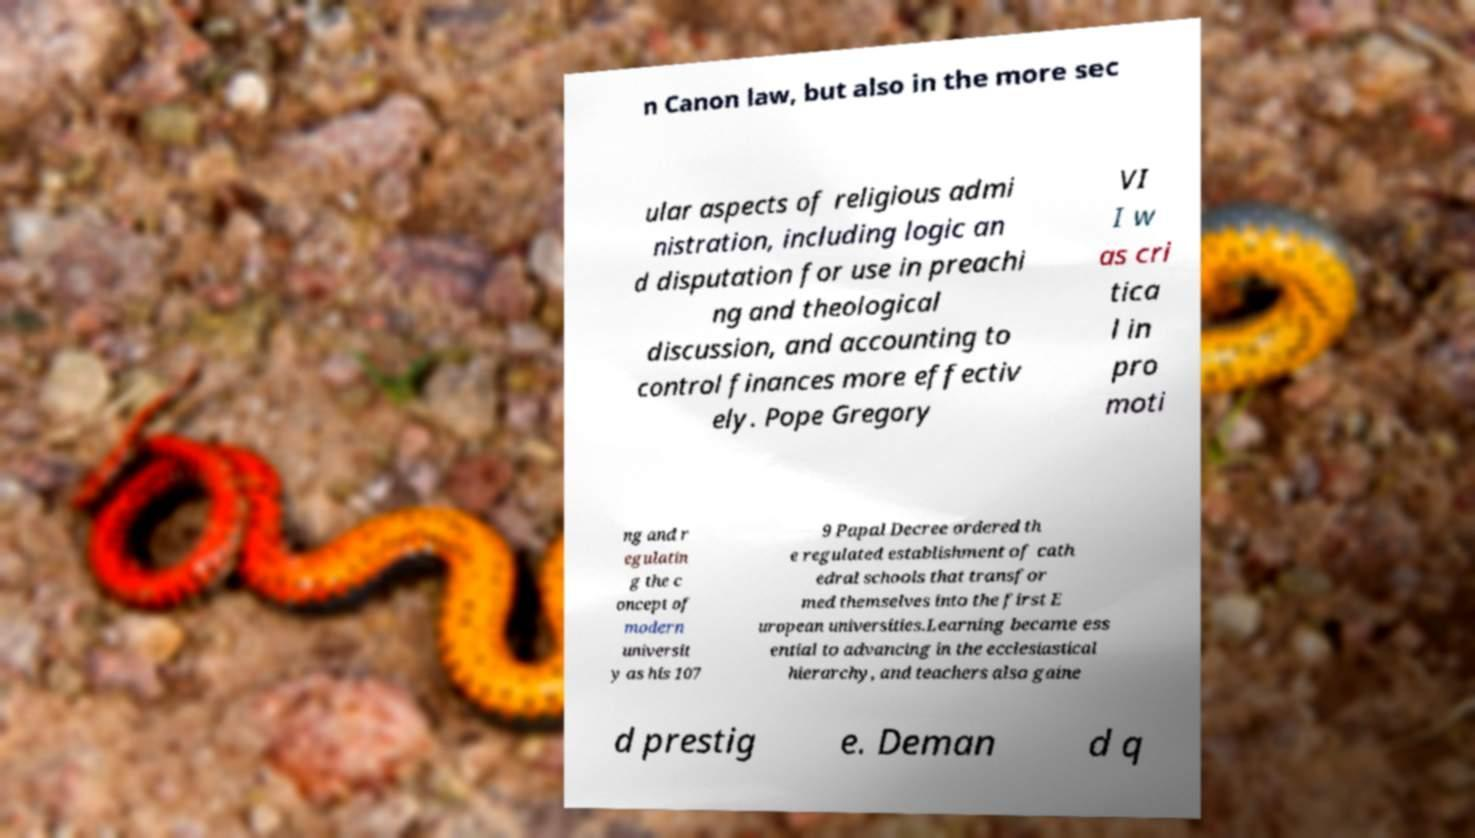Can you read and provide the text displayed in the image?This photo seems to have some interesting text. Can you extract and type it out for me? n Canon law, but also in the more sec ular aspects of religious admi nistration, including logic an d disputation for use in preachi ng and theological discussion, and accounting to control finances more effectiv ely. Pope Gregory VI I w as cri tica l in pro moti ng and r egulatin g the c oncept of modern universit y as his 107 9 Papal Decree ordered th e regulated establishment of cath edral schools that transfor med themselves into the first E uropean universities.Learning became ess ential to advancing in the ecclesiastical hierarchy, and teachers also gaine d prestig e. Deman d q 